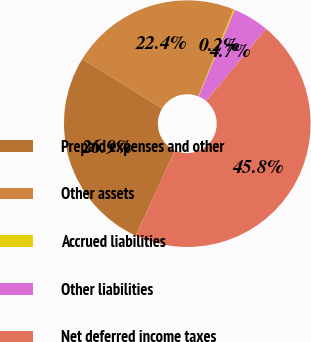<chart> <loc_0><loc_0><loc_500><loc_500><pie_chart><fcel>Prepaid expenses and other<fcel>Other assets<fcel>Accrued liabilities<fcel>Other liabilities<fcel>Net deferred income taxes<nl><fcel>26.91%<fcel>22.35%<fcel>0.18%<fcel>4.74%<fcel>45.82%<nl></chart> 